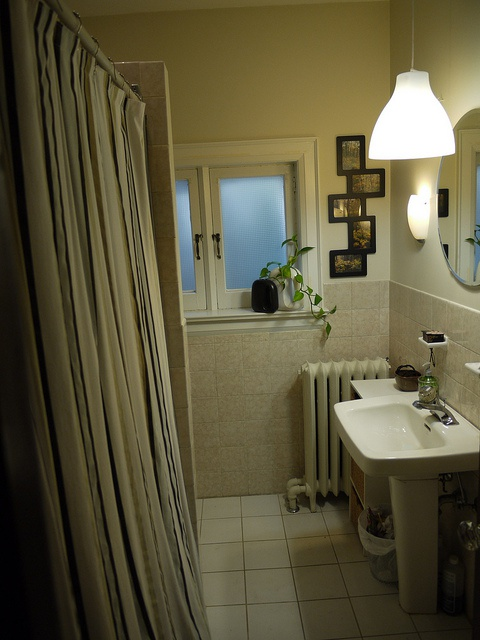Describe the objects in this image and their specific colors. I can see sink in black, darkgray, lightgray, and darkgreen tones, potted plant in black, darkgreen, and gray tones, and vase in black, gray, and navy tones in this image. 